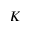Convert formula to latex. <formula><loc_0><loc_0><loc_500><loc_500>K</formula> 